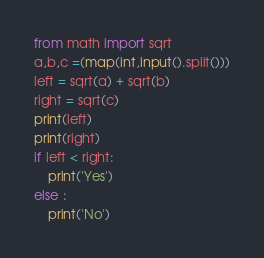<code> <loc_0><loc_0><loc_500><loc_500><_Python_>from math import sqrt
a,b,c =(map(int,input().split()))
left = sqrt(a) + sqrt(b)
right = sqrt(c)
print(left)
print(right)
if left < right:
    print('Yes')
else :
    print('No')</code> 